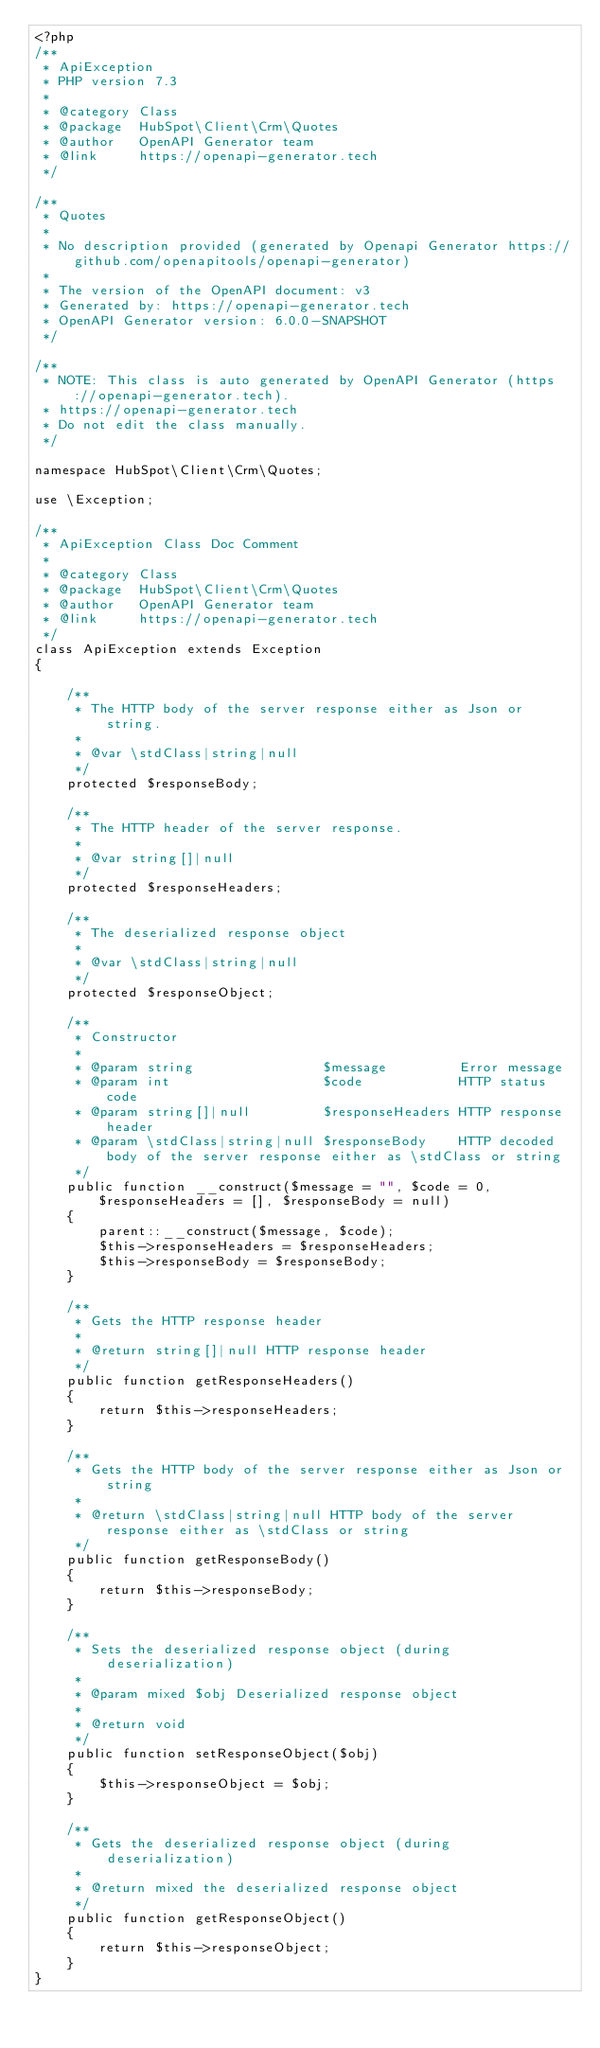<code> <loc_0><loc_0><loc_500><loc_500><_PHP_><?php
/**
 * ApiException
 * PHP version 7.3
 *
 * @category Class
 * @package  HubSpot\Client\Crm\Quotes
 * @author   OpenAPI Generator team
 * @link     https://openapi-generator.tech
 */

/**
 * Quotes
 *
 * No description provided (generated by Openapi Generator https://github.com/openapitools/openapi-generator)
 *
 * The version of the OpenAPI document: v3
 * Generated by: https://openapi-generator.tech
 * OpenAPI Generator version: 6.0.0-SNAPSHOT
 */

/**
 * NOTE: This class is auto generated by OpenAPI Generator (https://openapi-generator.tech).
 * https://openapi-generator.tech
 * Do not edit the class manually.
 */

namespace HubSpot\Client\Crm\Quotes;

use \Exception;

/**
 * ApiException Class Doc Comment
 *
 * @category Class
 * @package  HubSpot\Client\Crm\Quotes
 * @author   OpenAPI Generator team
 * @link     https://openapi-generator.tech
 */
class ApiException extends Exception
{

    /**
     * The HTTP body of the server response either as Json or string.
     *
     * @var \stdClass|string|null
     */
    protected $responseBody;

    /**
     * The HTTP header of the server response.
     *
     * @var string[]|null
     */
    protected $responseHeaders;

    /**
     * The deserialized response object
     *
     * @var \stdClass|string|null
     */
    protected $responseObject;

    /**
     * Constructor
     *
     * @param string                $message         Error message
     * @param int                   $code            HTTP status code
     * @param string[]|null         $responseHeaders HTTP response header
     * @param \stdClass|string|null $responseBody    HTTP decoded body of the server response either as \stdClass or string
     */
    public function __construct($message = "", $code = 0, $responseHeaders = [], $responseBody = null)
    {
        parent::__construct($message, $code);
        $this->responseHeaders = $responseHeaders;
        $this->responseBody = $responseBody;
    }

    /**
     * Gets the HTTP response header
     *
     * @return string[]|null HTTP response header
     */
    public function getResponseHeaders()
    {
        return $this->responseHeaders;
    }

    /**
     * Gets the HTTP body of the server response either as Json or string
     *
     * @return \stdClass|string|null HTTP body of the server response either as \stdClass or string
     */
    public function getResponseBody()
    {
        return $this->responseBody;
    }

    /**
     * Sets the deserialized response object (during deserialization)
     *
     * @param mixed $obj Deserialized response object
     *
     * @return void
     */
    public function setResponseObject($obj)
    {
        $this->responseObject = $obj;
    }

    /**
     * Gets the deserialized response object (during deserialization)
     *
     * @return mixed the deserialized response object
     */
    public function getResponseObject()
    {
        return $this->responseObject;
    }
}
</code> 